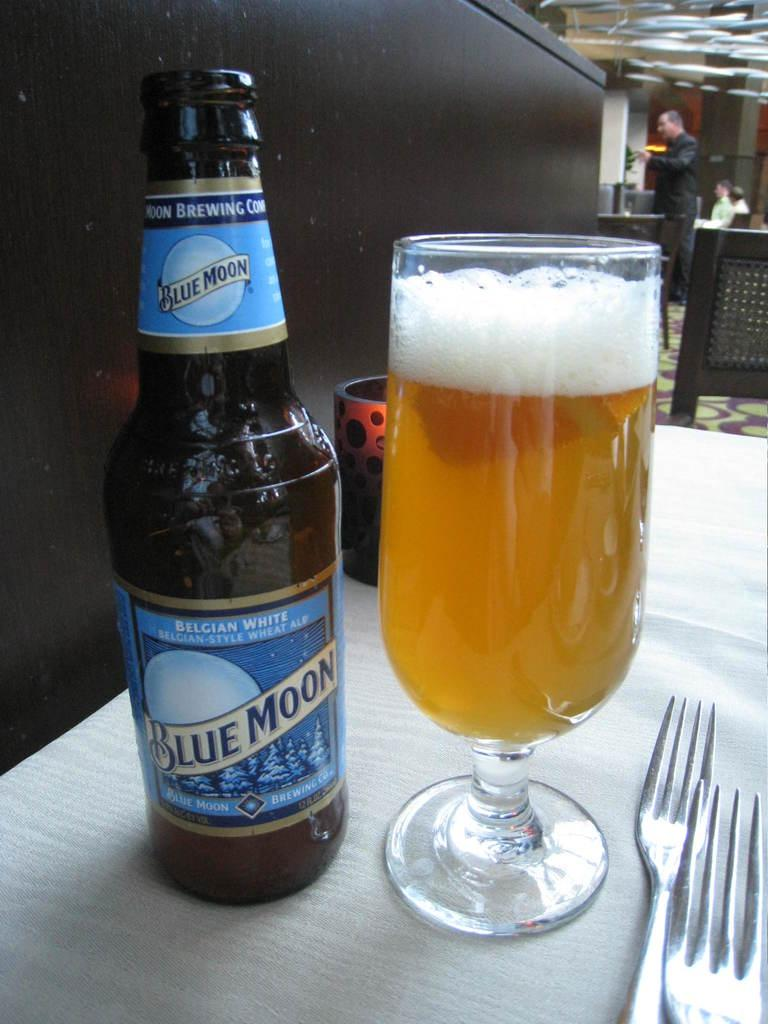<image>
Render a clear and concise summary of the photo. An open bottle of Blue Moon ale with a full glass next to it 